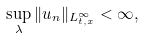<formula> <loc_0><loc_0><loc_500><loc_500>\sup _ { \lambda } \| u _ { n } \| _ { L ^ { \infty } _ { t , x } } < \infty ,</formula> 